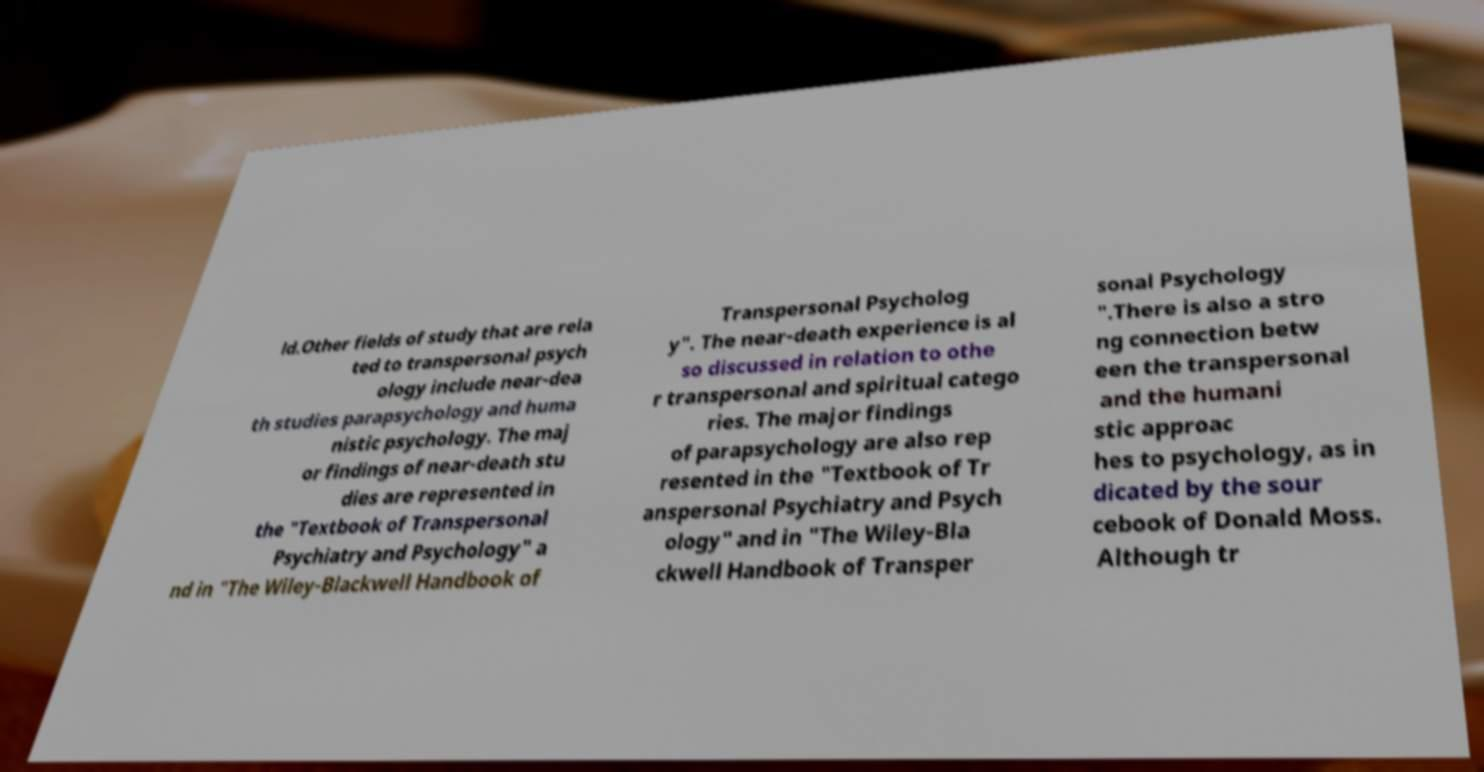For documentation purposes, I need the text within this image transcribed. Could you provide that? ld.Other fields of study that are rela ted to transpersonal psych ology include near-dea th studies parapsychology and huma nistic psychology. The maj or findings of near-death stu dies are represented in the "Textbook of Transpersonal Psychiatry and Psychology" a nd in "The Wiley-Blackwell Handbook of Transpersonal Psycholog y". The near-death experience is al so discussed in relation to othe r transpersonal and spiritual catego ries. The major findings of parapsychology are also rep resented in the "Textbook of Tr anspersonal Psychiatry and Psych ology" and in "The Wiley-Bla ckwell Handbook of Transper sonal Psychology ".There is also a stro ng connection betw een the transpersonal and the humani stic approac hes to psychology, as in dicated by the sour cebook of Donald Moss. Although tr 